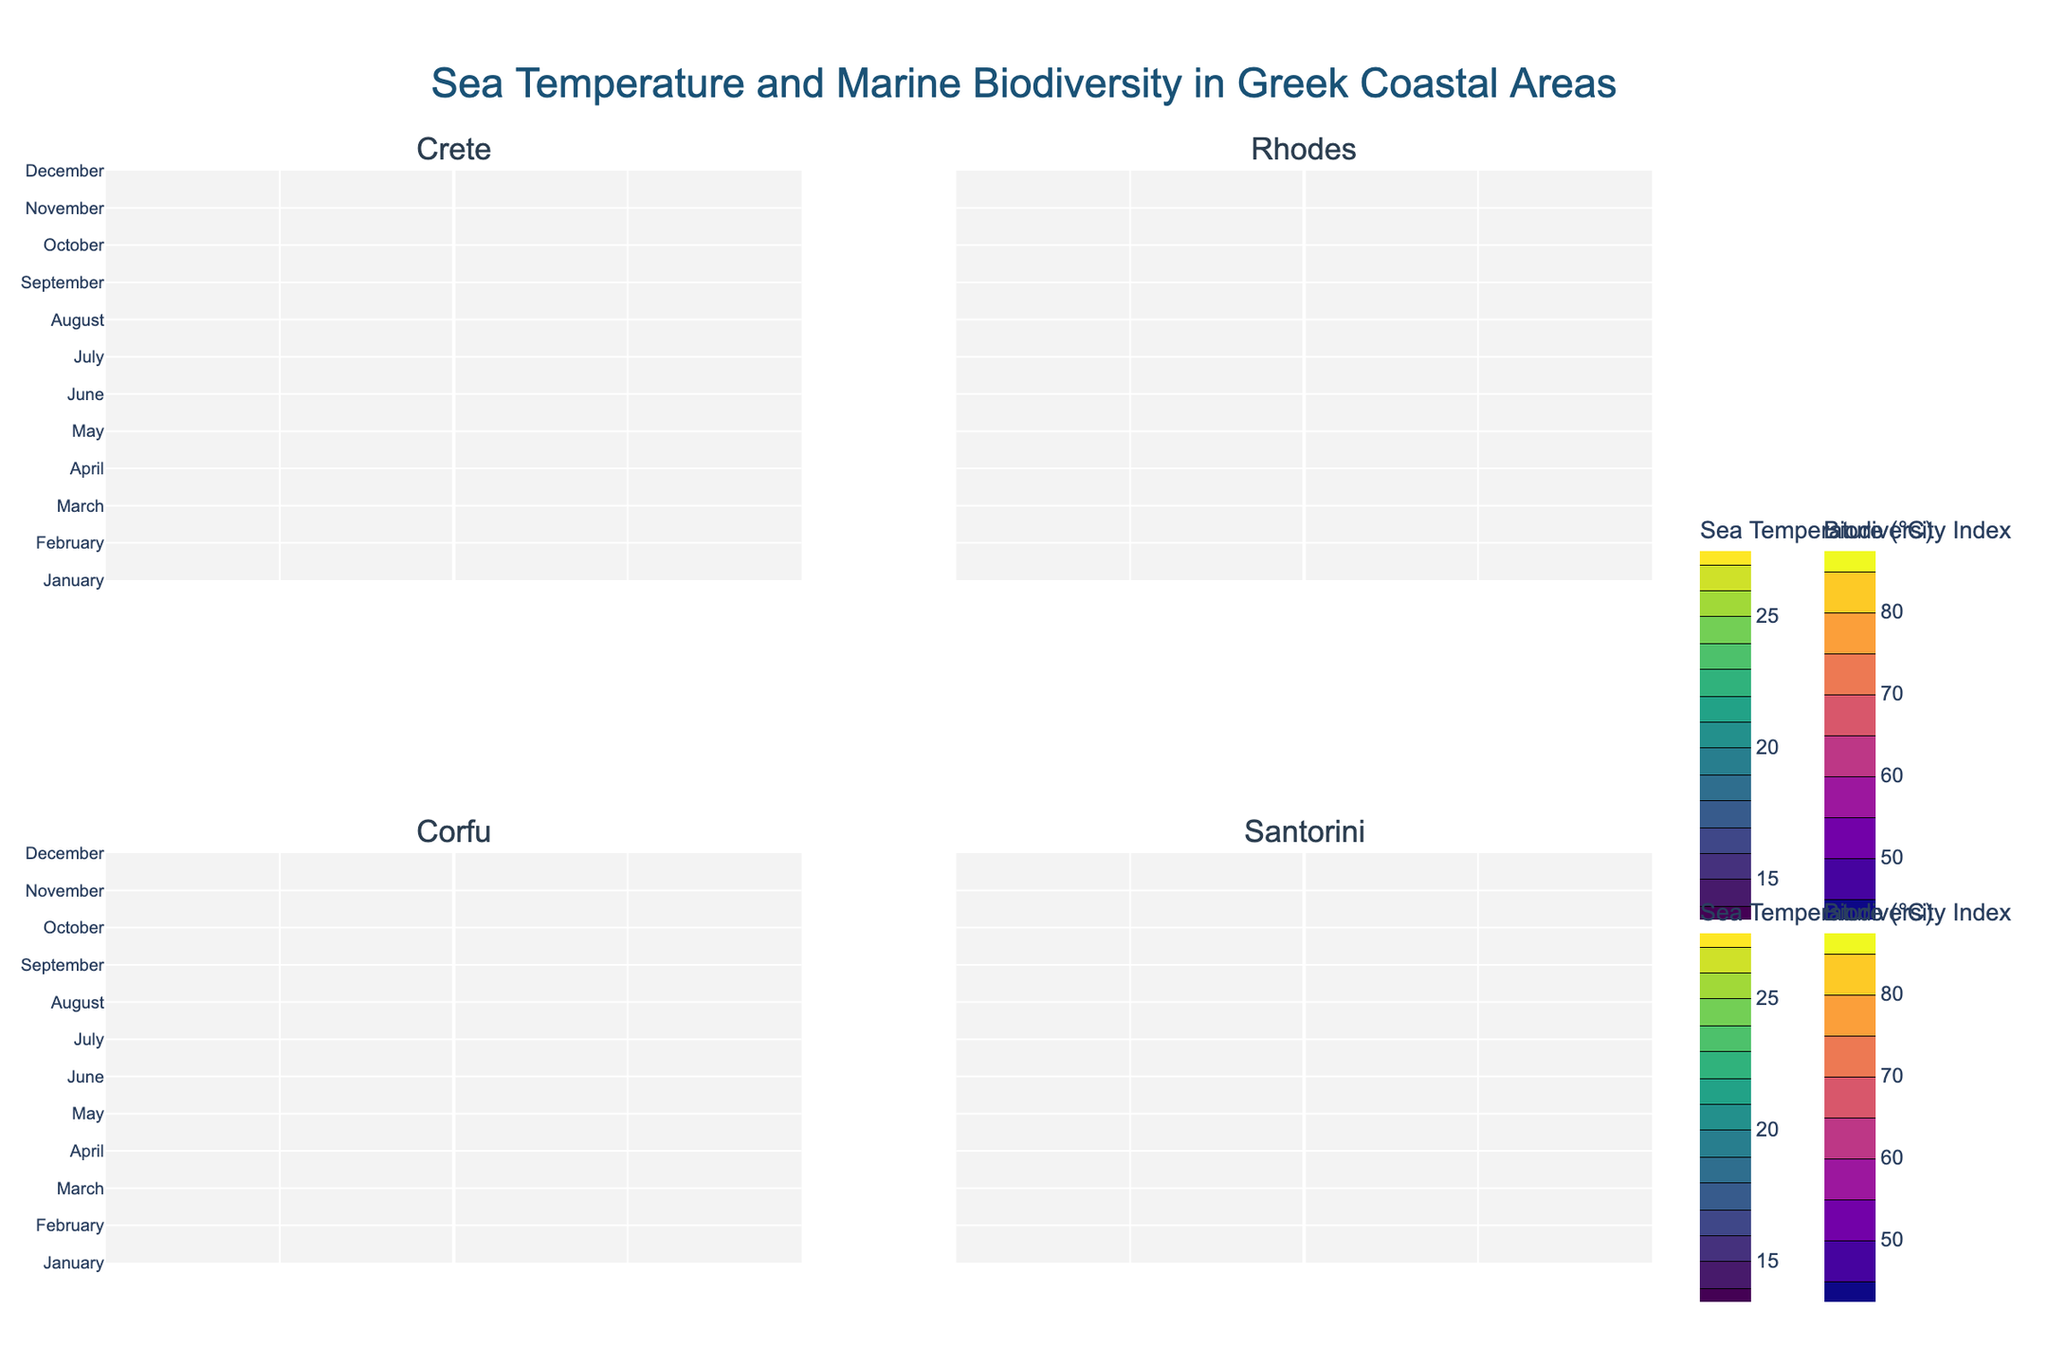What's the title of the figure? The title of the figure can be found at the top and is typically bold and in a larger font size. In this case, it reads "Sea Temperature and Marine Biodiversity in Greek Coastal Areas".
Answer: Sea Temperature and Marine Biodiversity in Greek Coastal Areas Which months show the highest sea temperature in Crete? In the Crete subplot, the contour plot with the Viridis color scale shows the highest sea temperatures (in darker shades). This usually corresponds to mid-summer months.
Answer: July and August How does the marine biodiversity index in Corfu change from January to December? To answer this question, examine the Corfu subplot using the contour plot in Plasma color scale. The indexes change from lighter to darker shades over the months.
Answer: It increases from January to December Which location has the highest marine biodiversity index in August? Look at all the subplots under the Plasma color scale for August and check the value contours for the highest index, focusing on darker shades. Santorini shows the highest value.
Answer: Santorini Compare the sea temperatures between Crete and Santorini in June. Which is higher? Compare the contour lines colored using the Viridis color scale for June in both the Crete and Santorini subplots. Santorini shows a slightly higher temperature in June.
Answer: Santorini Which location shows the lowest marine biodiversity index in February? Check all subplots with Plasma color scale for February, focusing on the lightest shades which indicate lower indexes. Corfu has the lowest index in February.
Answer: Corfu What is the range of the sea temperatures observed in Rhodes? Examine the contour lines in the Rhodes subplot (Viridis color scale) spanning from the lowest to highest values. The range can be observed directly from the color bar or contour lines.
Answer: 15.6°C to 25.4°C During which month does Santorini first reach the 20°C sea temperature mark? Look at the contour lines in the Santorini subplot using the Viridis color scale, and find the month associated with the 20°C iso-line.
Answer: May Compare the marine biodiversity index in November between Crete and Rhodes. Which one is higher? Look at the contour lines in the Crete and Rhodes subplots in November using the Plasma color scale, and compare their values. Crete shows a higher value.
Answer: Crete 